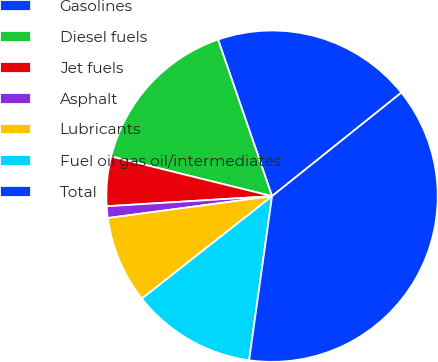Convert chart to OTSL. <chart><loc_0><loc_0><loc_500><loc_500><pie_chart><fcel>Gasolines<fcel>Diesel fuels<fcel>Jet fuels<fcel>Asphalt<fcel>Lubricants<fcel>Fuel oil gas oil/intermediates<fcel>Total<nl><fcel>19.54%<fcel>15.86%<fcel>4.82%<fcel>1.14%<fcel>8.5%<fcel>12.18%<fcel>37.95%<nl></chart> 